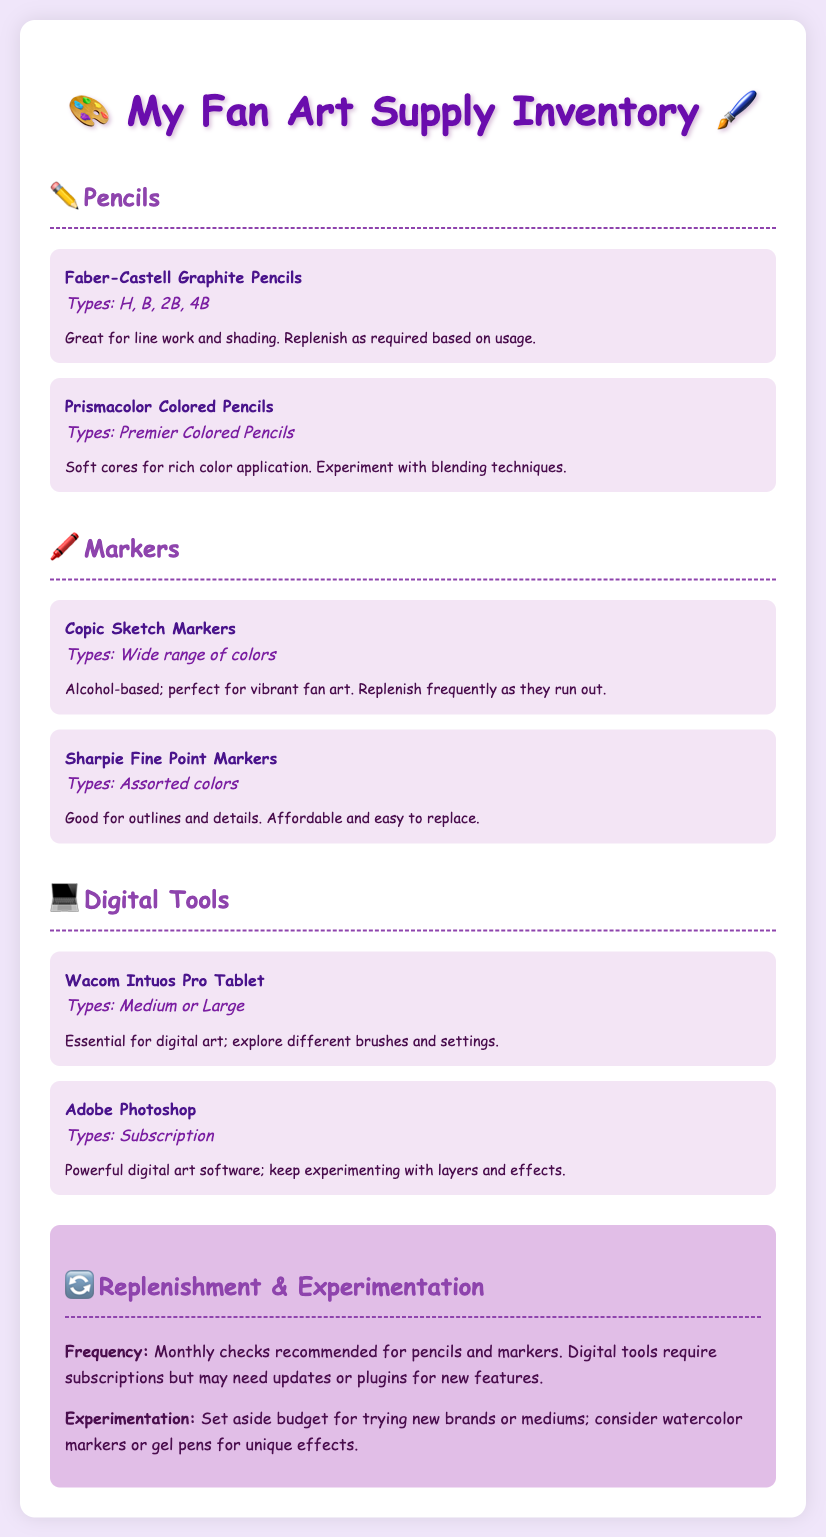What is the name of the first pencil listed? The first pencil mentioned in the document is the Faber-Castell Graphite Pencils, which is part of the pencils section.
Answer: Faber-Castell Graphite Pencils How many types of Faber-Castell Graphite Pencils are mentioned? The document lists four types (H, B, 2B, 4B) under the Faber-Castell Graphite Pencils.
Answer: 4 What is the purpose of Copic Sketch Markers? The Copic Sketch Markers are described as perfect for vibrant fan art, which indicates their intended use.
Answer: Vibrant fan art What is suggested for monthly checks? The document recommends monthly checks for pencils and markers, indicating a routine maintenance schedule.
Answer: Pencils and markers What type of digital tool is mentioned with Adobe Photoshop? The Wacom Intuos Pro Tablet is mentioned alongside Adobe Photoshop as a necessary tool for digital art.
Answer: Wacom Intuos Pro Tablet What is one type of new material suggested for experimentation? The document mentions considering watercolor markers or gel pens as potential new materials to experiment with in art.
Answer: Watercolor markers What color are Sharpie Fine Point Markers? The Sharpie Fine Point Markers are available in assorted colors, showcasing their variety.
Answer: Assorted colors How often should replenishment checks be made? The document recommends monthly checks for certain supplies, indicating a frequency for maintenance of the inventory.
Answer: Monthly What are the two types of Wacom Intuos Pro Tablets mentioned? The document specifies that the Wacom Intuos Pro Tablet is available in medium or large sizes.
Answer: Medium or large 